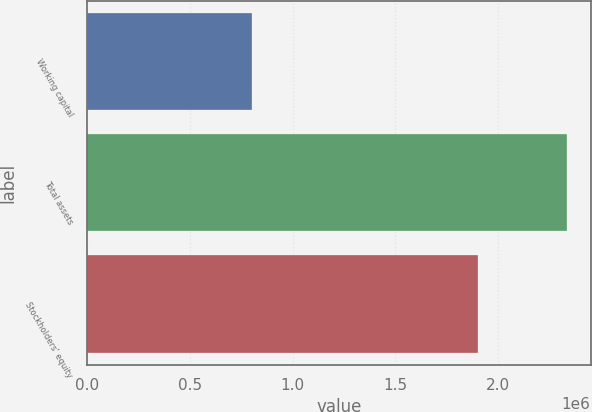Convert chart. <chart><loc_0><loc_0><loc_500><loc_500><bar_chart><fcel>Working capital<fcel>Total assets<fcel>Stockholders' equity<nl><fcel>802913<fcel>2.33536e+06<fcel>1.90374e+06<nl></chart> 